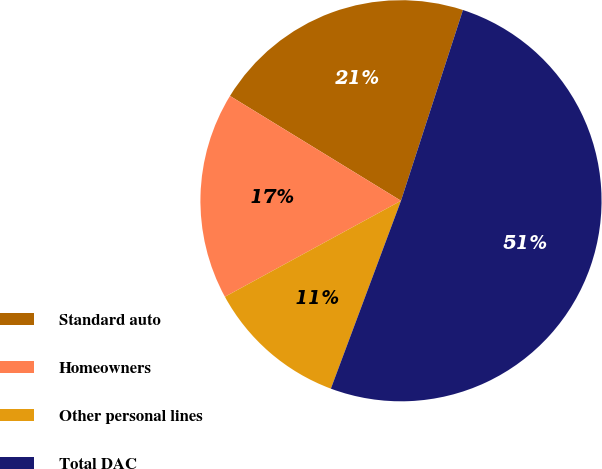Convert chart. <chart><loc_0><loc_0><loc_500><loc_500><pie_chart><fcel>Standard auto<fcel>Homeowners<fcel>Other personal lines<fcel>Total DAC<nl><fcel>21.25%<fcel>16.7%<fcel>11.37%<fcel>50.69%<nl></chart> 